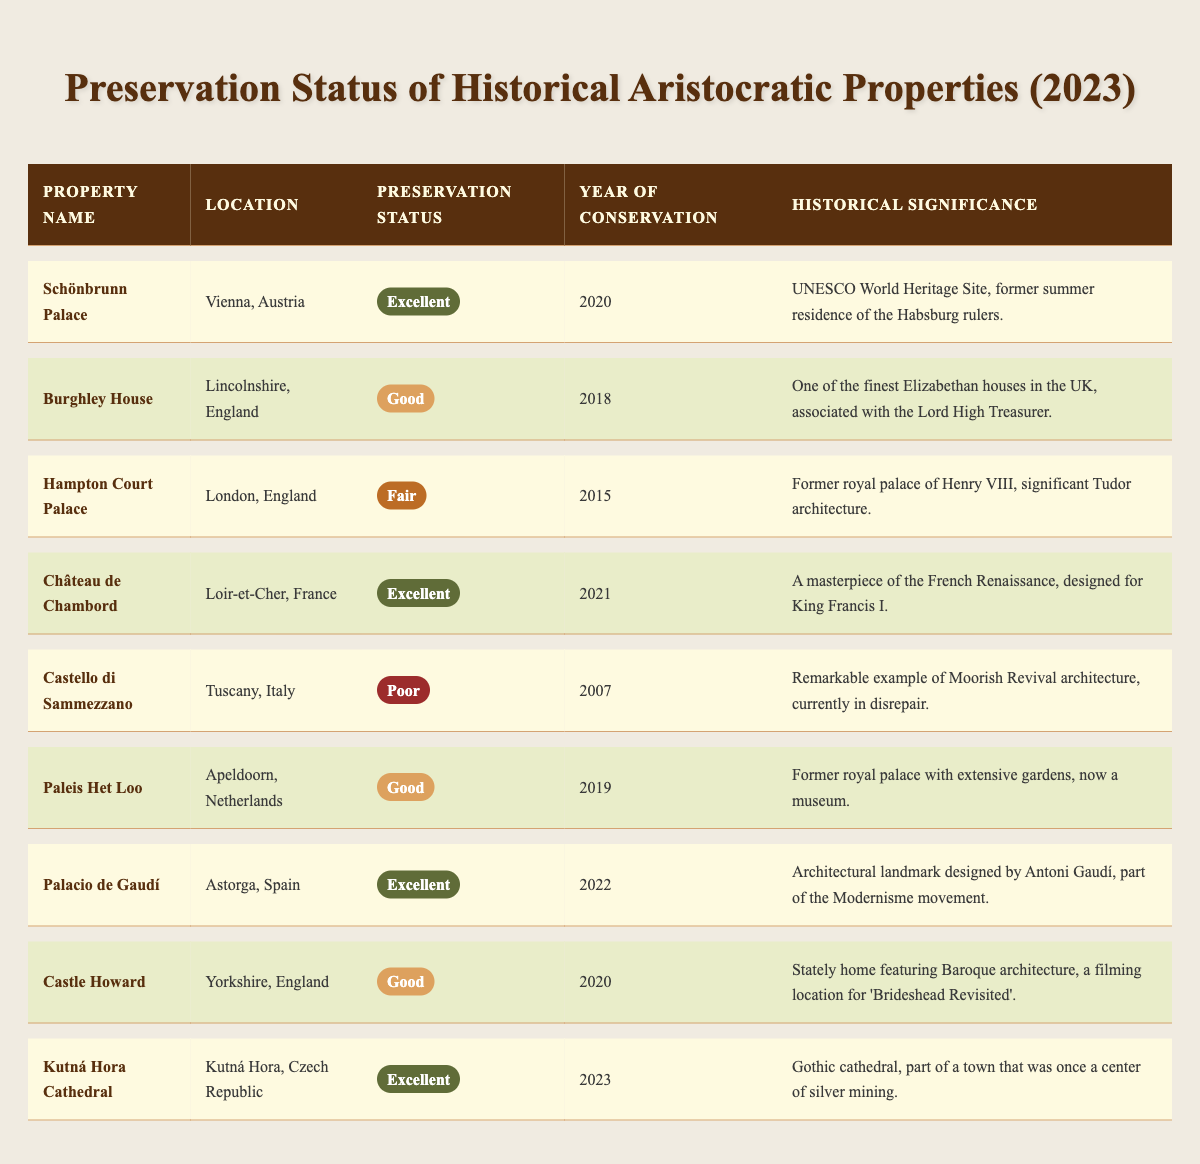What is the preservation status of Château de Chambord? The table shows that Château de Chambord has a preservation status labeled as "Excellent."
Answer: Excellent How many properties have a preservation status of "Good"? There are three properties listed with the preservation status "Good": Burghley House, Paleis Het Loo, and Castle Howard.
Answer: 3 Which property was conserved most recently? The table indicates that Kutná Hora Cathedral was conserved in 2023, which is the most recent year listed for conservation.
Answer: Kutná Hora Cathedral Is there any property with a preservation status of "Poor"? Yes, Castello di Sammezzano is the only property with a preservation status of "Poor."
Answer: Yes How many properties are classified as "Excellent"? The properties classified as "Excellent" are Schönbrunn Palace, Château de Chambord, Palacio de Gaudí, and Kutná Hora Cathedral, totaling four.
Answer: 4 What is the historical significance of Hampton Court Palace? According to the table, Hampton Court Palace is significant as the former royal palace of Henry VIII, showcasing significant Tudor architecture.
Answer: Former royal palace of Henry VIII What year was Castello di Sammezzano conserved, and what is its preservation status? The table states that Castello di Sammezzano was conserved in 2007, and it has a preservation status of "Poor."
Answer: 2007, Poor Which locations feature properties with the "Fair" preservation status? The only location with a property rated "Fair" is London, England, where Hampton Court Palace is situated.
Answer: London, England How does the preservation status of Paleis Het Loo compare to that of Hampton Court Palace? Paleis Het Loo has a preservation status of "Good," while Hampton Court Palace has "Fair." Therefore, Paleis Het Loo is better preserved than Hampton Court Palace.
Answer: Better Of the properties listed, which has the earliest year of conservation? Castello di Sammezzano has the earliest year of conservation listed in the table, which is 2007.
Answer: Castello di Sammezzano Which property is associated with the Modernisme movement? The table notes that Palacio de Gaudí, located in Astorga, Spain, is the property associated with the Modernisme movement.
Answer: Palacio de Gaudí 